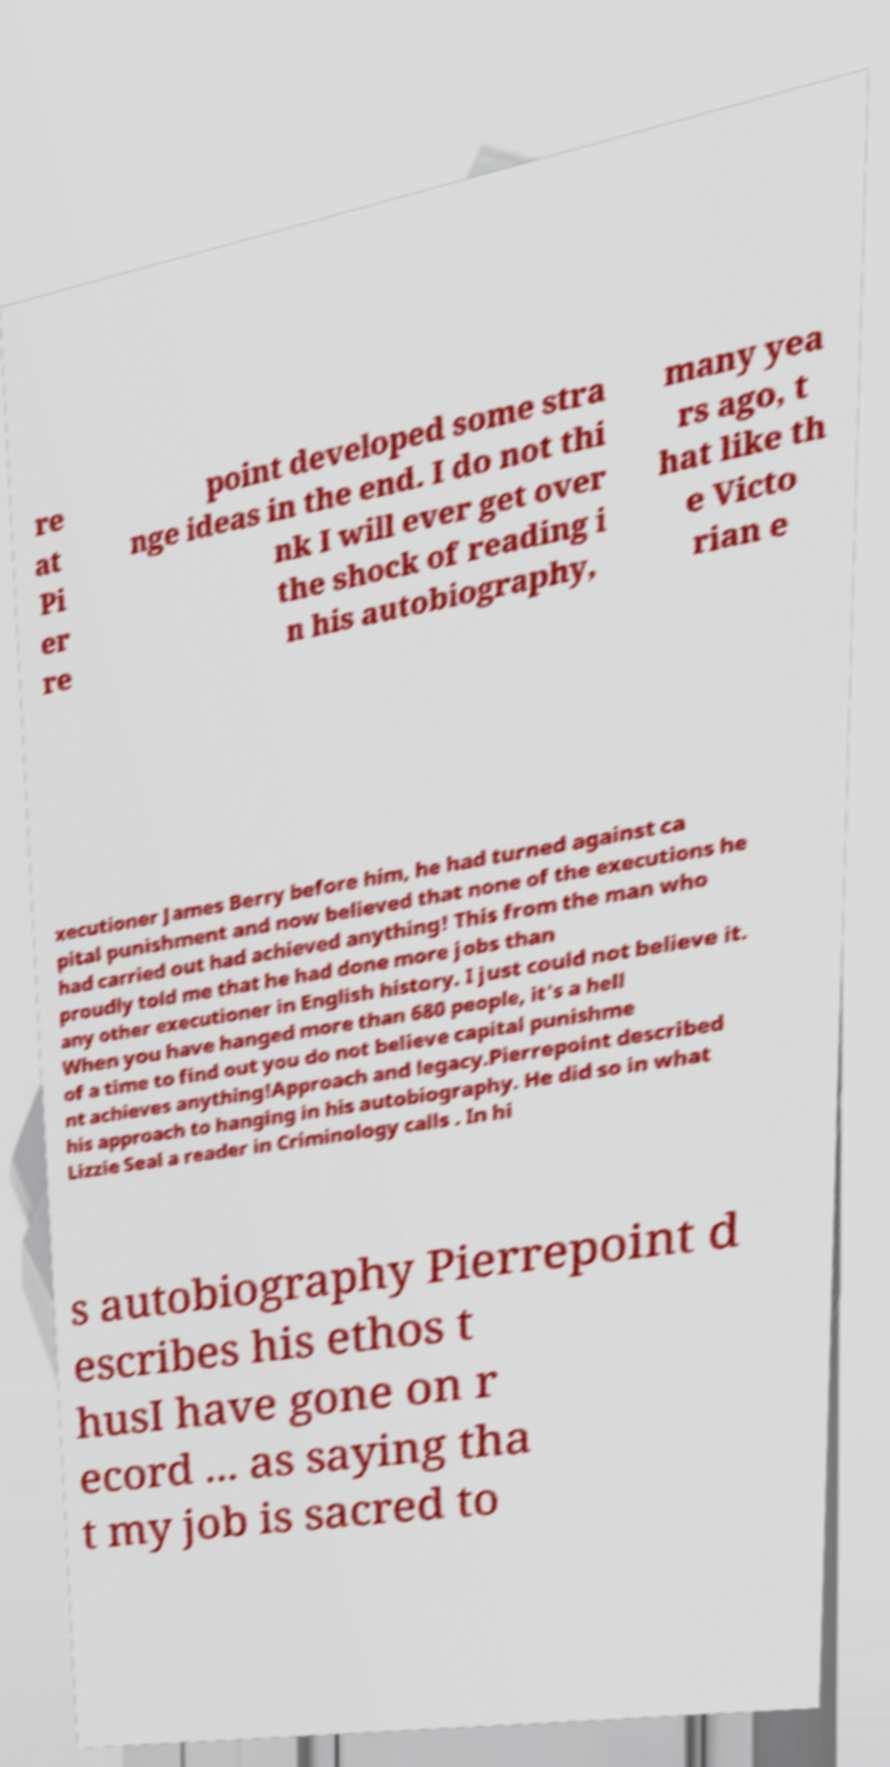I need the written content from this picture converted into text. Can you do that? re at Pi er re point developed some stra nge ideas in the end. I do not thi nk I will ever get over the shock of reading i n his autobiography, many yea rs ago, t hat like th e Victo rian e xecutioner James Berry before him, he had turned against ca pital punishment and now believed that none of the executions he had carried out had achieved anything! This from the man who proudly told me that he had done more jobs than any other executioner in English history. I just could not believe it. When you have hanged more than 680 people, it's a hell of a time to find out you do not believe capital punishme nt achieves anything!Approach and legacy.Pierrepoint described his approach to hanging in his autobiography. He did so in what Lizzie Seal a reader in Criminology calls . In hi s autobiography Pierrepoint d escribes his ethos t husI have gone on r ecord ... as saying tha t my job is sacred to 